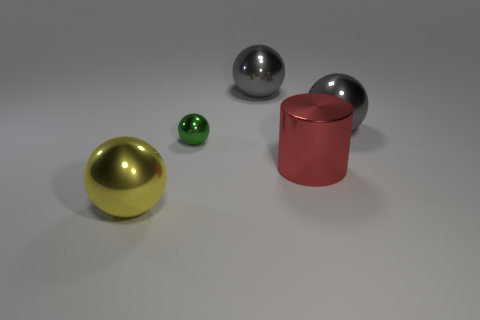Do the yellow ball to the left of the tiny green metal thing and the tiny ball have the same material?
Offer a terse response. Yes. Is there any other thing that is the same size as the green shiny sphere?
Provide a succinct answer. No. Is the number of big cylinders to the left of the green thing less than the number of balls that are left of the big yellow metallic object?
Offer a very short reply. No. Is there anything else that is the same shape as the big red metallic thing?
Your response must be concise. No. There is a large gray ball to the right of the big red thing in front of the tiny green metal object; how many yellow metallic things are right of it?
Keep it short and to the point. 0. What number of balls are right of the small metal object?
Provide a succinct answer. 2. What number of small spheres have the same material as the small thing?
Your response must be concise. 0. There is a small ball that is made of the same material as the large cylinder; what color is it?
Provide a succinct answer. Green. The gray object that is on the left side of the large gray ball that is on the right side of the large red metal cylinder in front of the small green object is made of what material?
Provide a succinct answer. Metal. There is a green sphere that is behind the red metal cylinder; is it the same size as the large red thing?
Keep it short and to the point. No. 